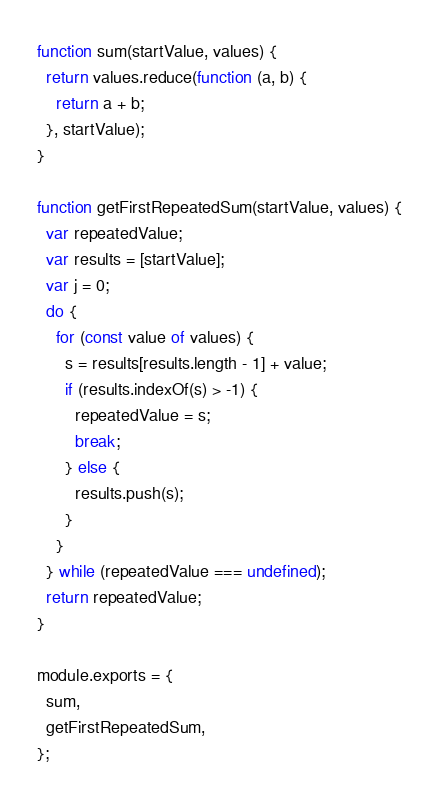Convert code to text. <code><loc_0><loc_0><loc_500><loc_500><_JavaScript_>function sum(startValue, values) {
  return values.reduce(function (a, b) {
    return a + b;
  }, startValue);
}

function getFirstRepeatedSum(startValue, values) {
  var repeatedValue;
  var results = [startValue];
  var j = 0;
  do {
    for (const value of values) {
      s = results[results.length - 1] + value;
      if (results.indexOf(s) > -1) {
        repeatedValue = s;
        break;
      } else {
        results.push(s);
      }
    }
  } while (repeatedValue === undefined);
  return repeatedValue;
}

module.exports = {
  sum,
  getFirstRepeatedSum,
};
</code> 